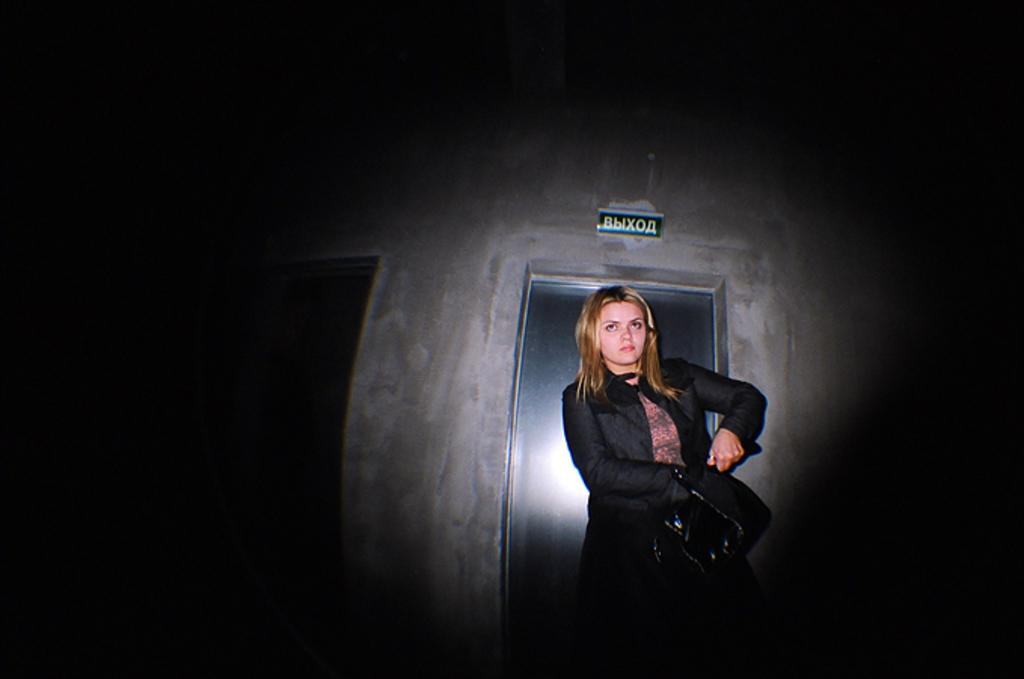Who is present in the image? There is a woman in the image. What can be observed about the background of the image? The background of the image is dark. What type of juice is the woman holding in the image? There is no juice present in the image; only the woman and the dark background can be observed. 